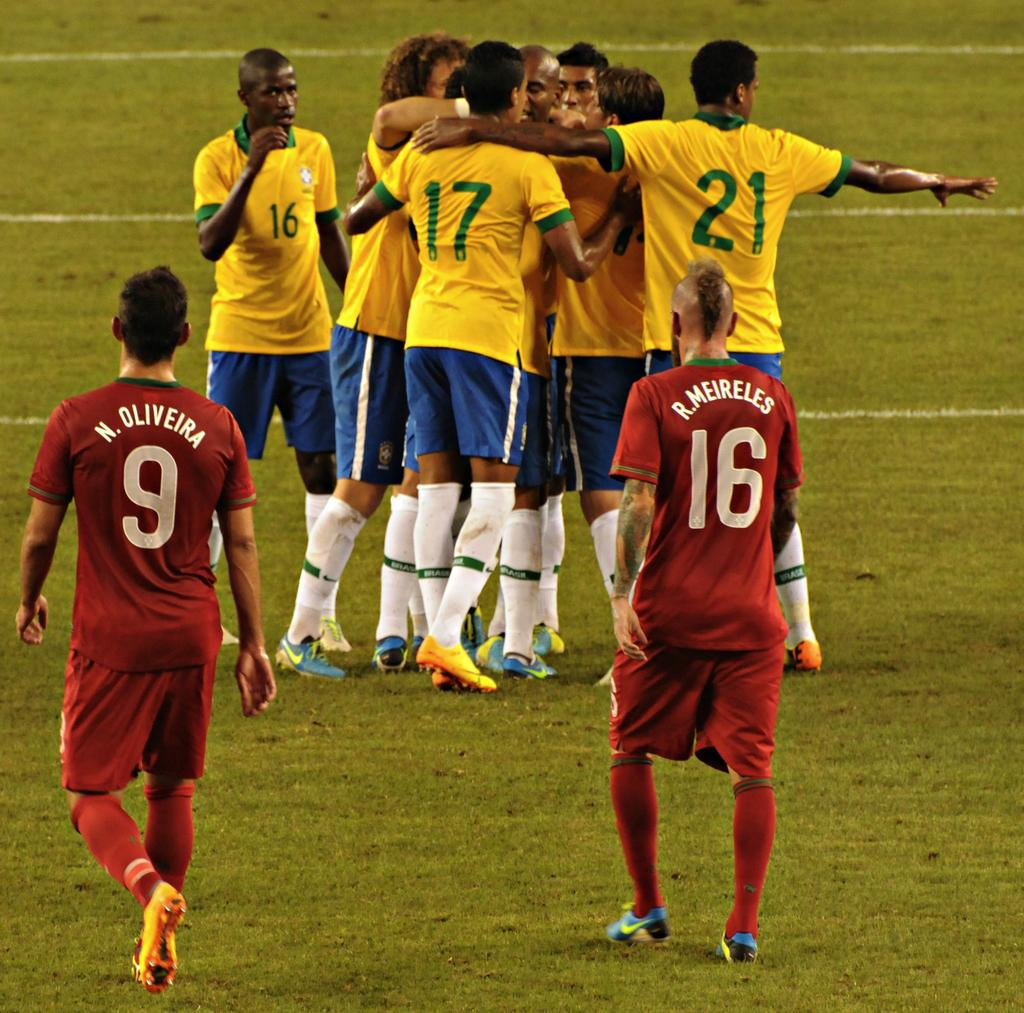<image>
Describe the image concisely. Meireles and Oliveira in red soccer jerseys stand looking at the team members in yellow jerseys hugging. 